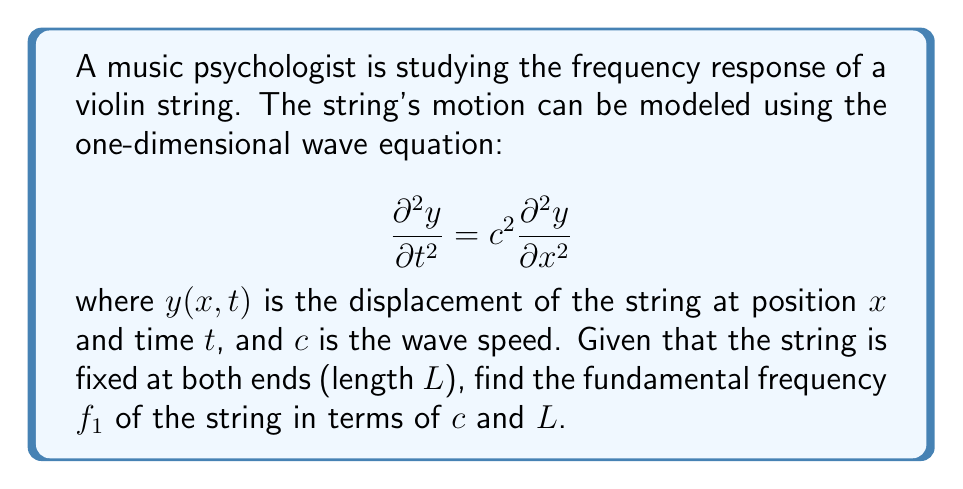Could you help me with this problem? 1) The general solution to the wave equation for a string fixed at both ends is:

   $$y(x,t) = \sum_{n=1}^{\infty} A_n \sin(\frac{n\pi x}{L}) \cos(\frac{n\pi c t}{L})$$

2) The term $\frac{n\pi c}{L}$ represents the angular frequency $\omega_n$ for each mode $n$:

   $$\omega_n = \frac{n\pi c}{L}$$

3) The fundamental frequency corresponds to $n=1$:

   $$\omega_1 = \frac{\pi c}{L}$$

4) Convert angular frequency to regular frequency using $f = \frac{\omega}{2\pi}$:

   $$f_1 = \frac{\omega_1}{2\pi} = \frac{\pi c}{L} \cdot \frac{1}{2\pi} = \frac{c}{2L}$$

5) Therefore, the fundamental frequency $f_1$ is given by:

   $$f_1 = \frac{c}{2L}$$

This equation shows that the fundamental frequency is directly proportional to the wave speed and inversely proportional to the length of the string, which aligns with the physical intuition of string instruments.
Answer: $f_1 = \frac{c}{2L}$ 